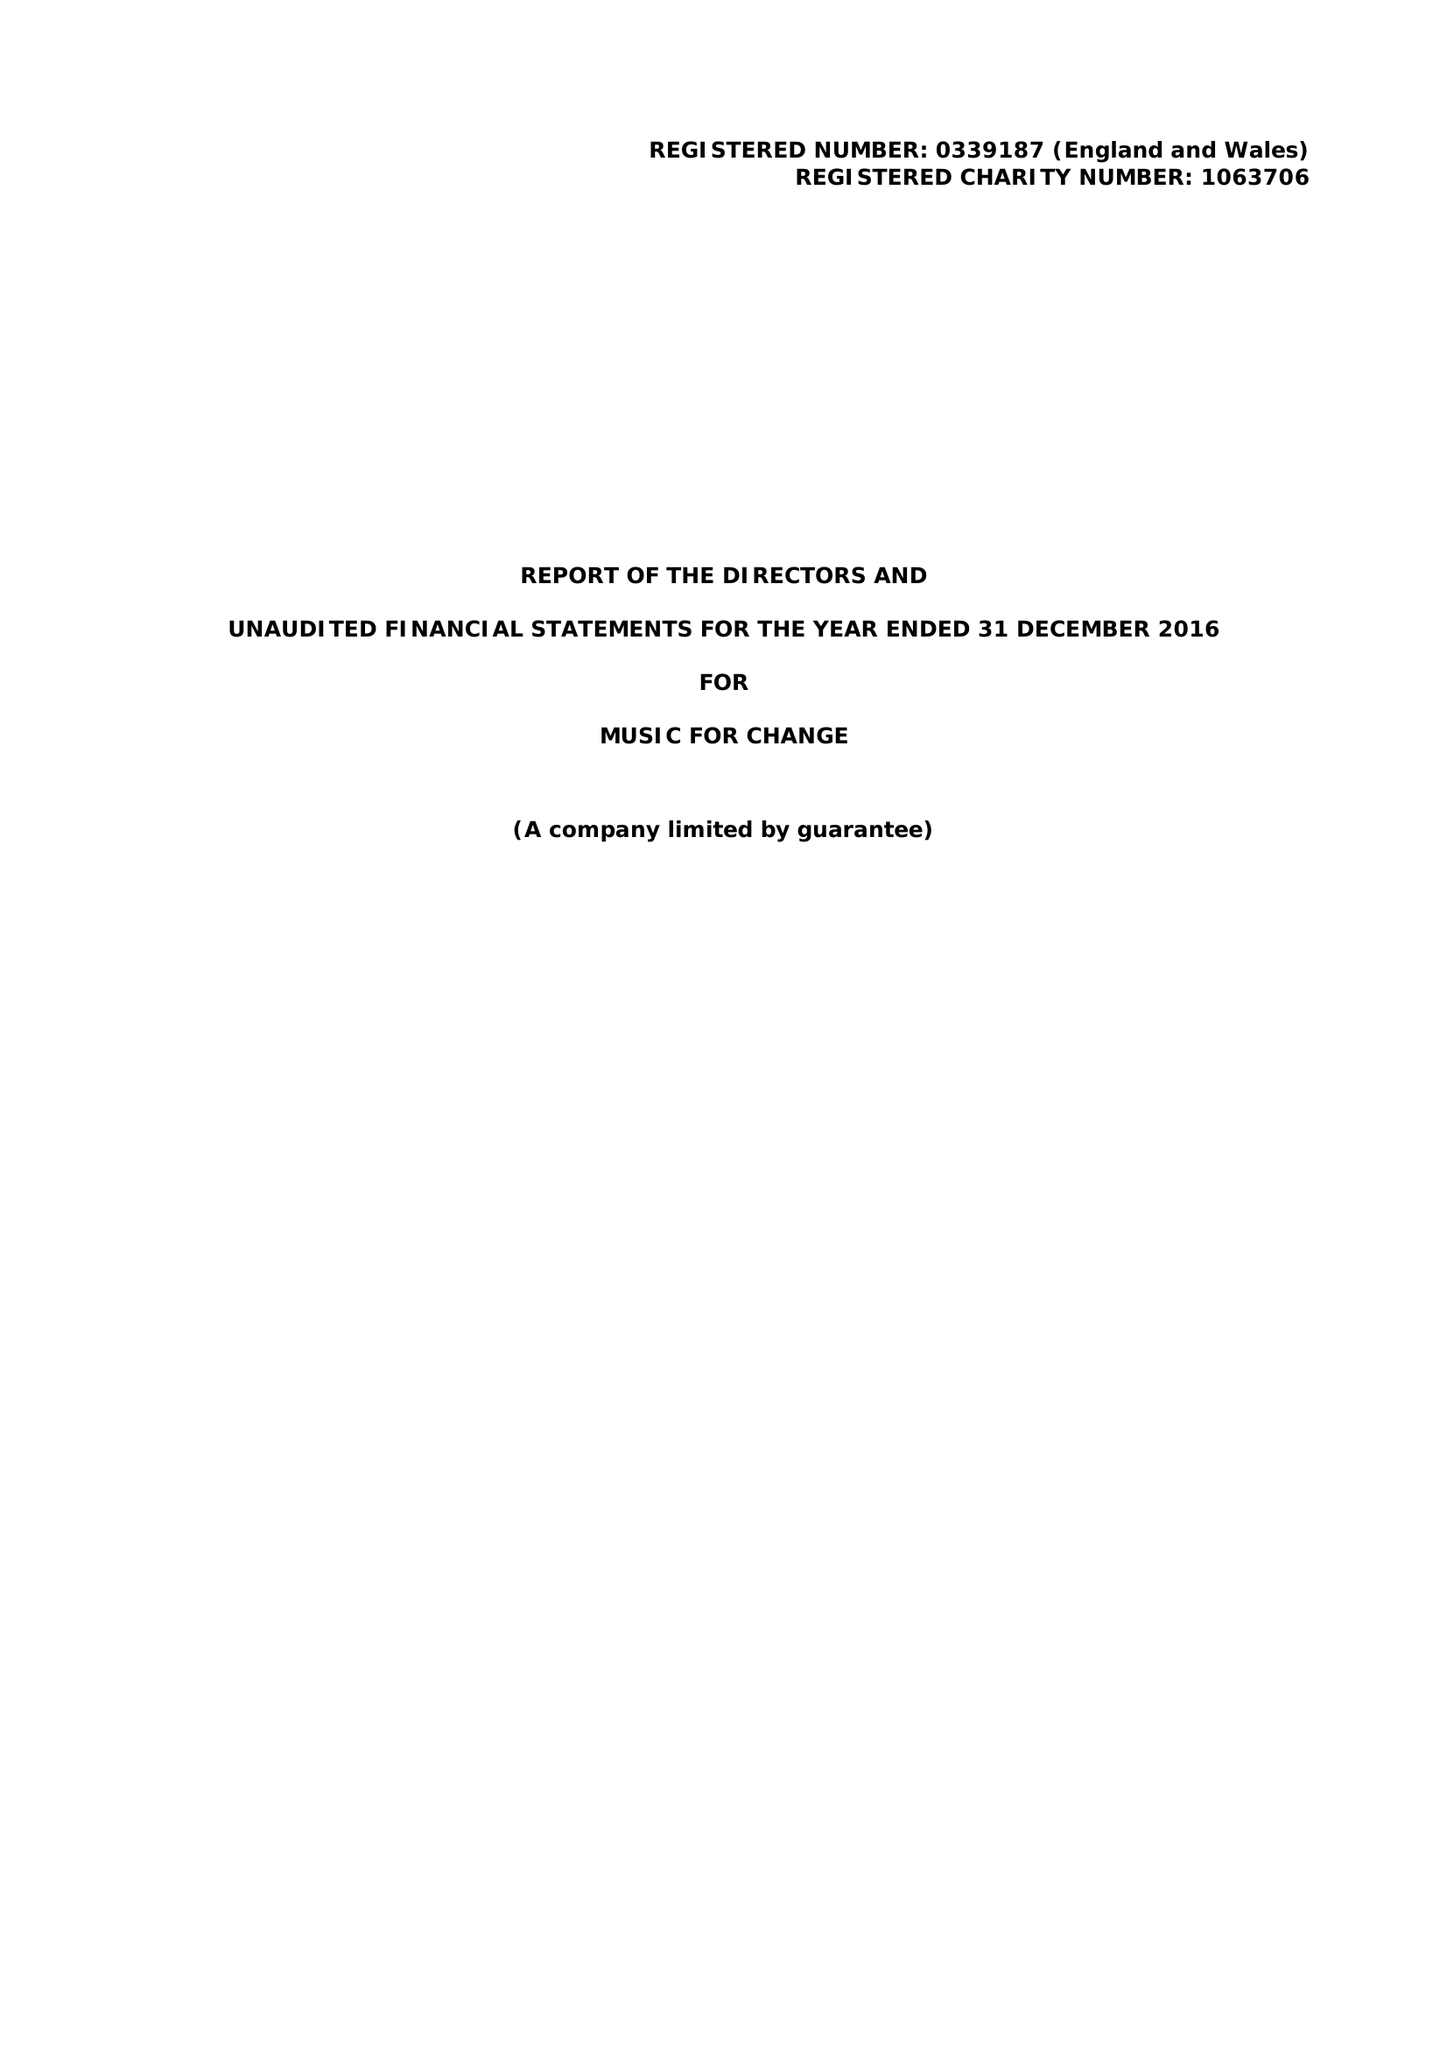What is the value for the spending_annually_in_british_pounds?
Answer the question using a single word or phrase. 130973.00 